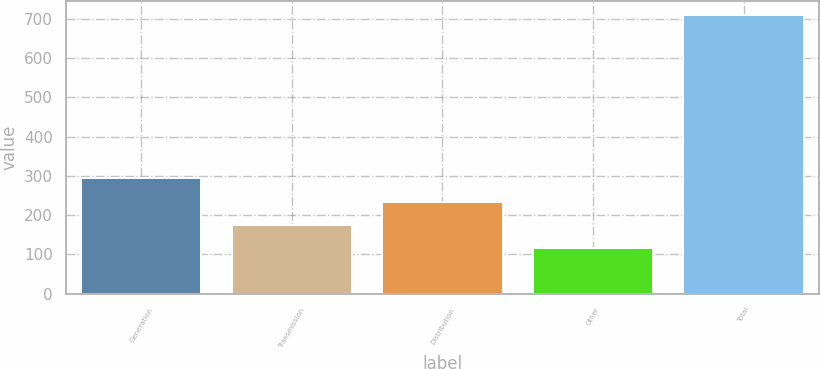Convert chart to OTSL. <chart><loc_0><loc_0><loc_500><loc_500><bar_chart><fcel>Generation<fcel>Transmission<fcel>Distribution<fcel>Other<fcel>Total<nl><fcel>293.5<fcel>174.5<fcel>234<fcel>115<fcel>710<nl></chart> 